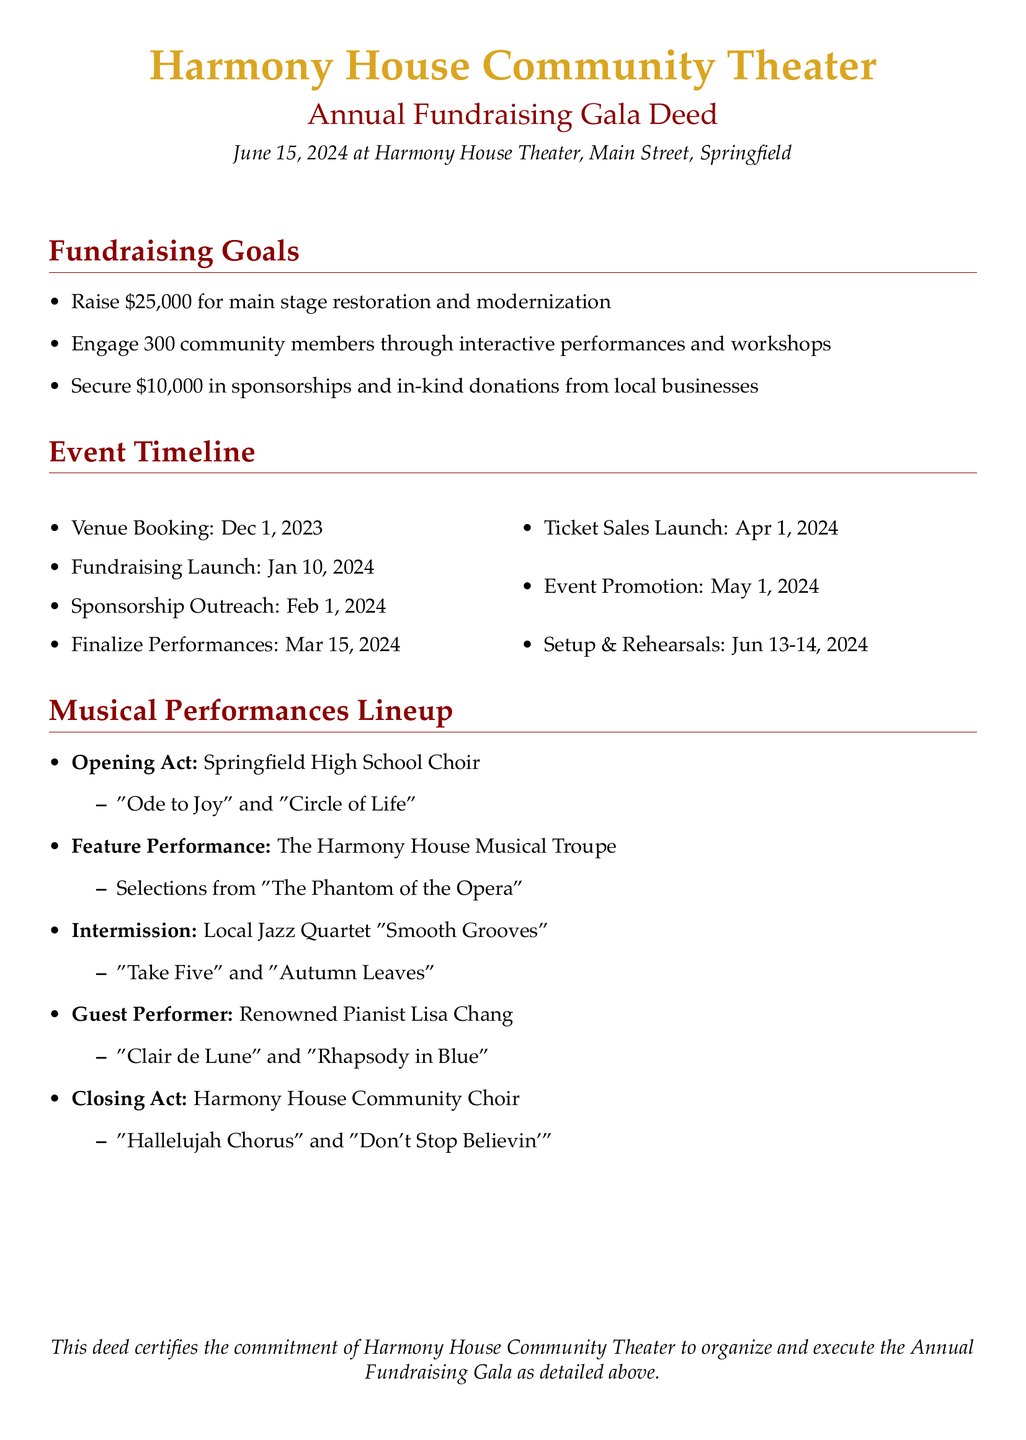What is the date of the fundraising gala? The date of the fundraising gala is explicitly mentioned in the document, which is June 15, 2024.
Answer: June 15, 2024 What is the fundraising goal for main stage restoration? The document lists specific fundraising goals, including one that states \$25,000 for main stage restoration and modernization.
Answer: \$25,000 How many community members does the event aim to engage? The document specifies an engagement goal of 300 community members through interactive performances and workshops.
Answer: 300 Who is performing the feature performance? The document identifies the Harmony House Musical Troupe as the group performing the feature performance.
Answer: The Harmony House Musical Troupe What are the names of two pieces performed by the Springfield High School Choir? The document lists the choir's opening pieces which are "Ode to Joy" and "Circle of Life."
Answer: "Ode to Joy" and "Circle of Life" When does ticket sales launch? The timeline indicates that ticket sales will launch on April 1, 2024.
Answer: April 1, 2024 What is the role of Lisa Chang in the event? The document specifies that Lisa Chang is a guest performer in the fundraising gala.
Answer: Guest Performer What is the closing act for the gala? The closing act, as outlined in the document, is the Harmony House Community Choir.
Answer: Harmony House Community Choir 